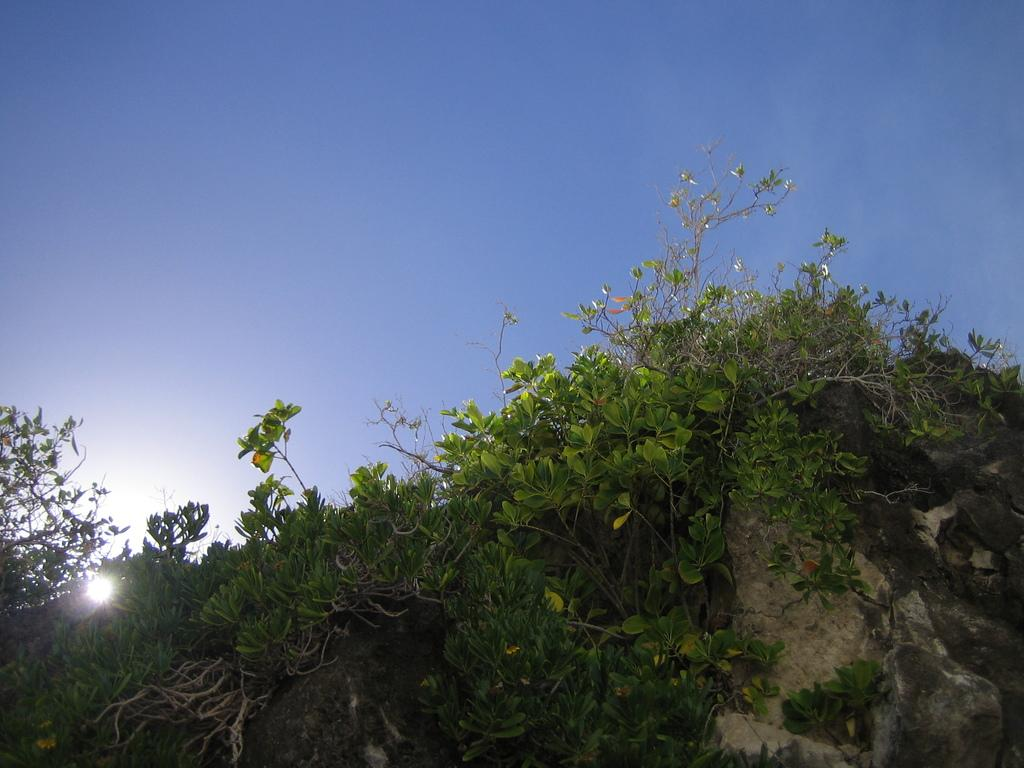What type of natural elements can be seen in the image? There are rocks and plants in the image. What additional details can be observed about the plants? There are leaves in the image. What celestial body is visible in the image? The sun is visible in the image. What can be seen in the background of the image? There is sky visible in the background of the image. What type of creature is flying around the rocks in the image? There is no creature flying around the rocks in the image. Can you tell me how the plants and rocks express their love for each other in the image? The plants and rocks do not express love for each other in the image, as they are inanimate objects. 